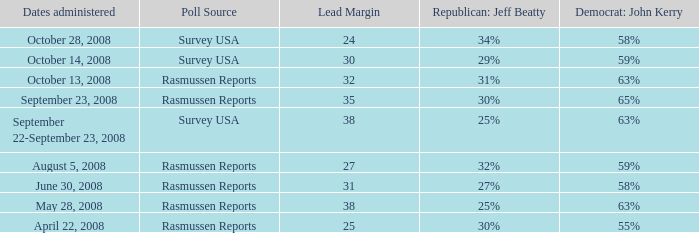What is the percent for john kerry and dates managed is april 22, 2008? 55%. 